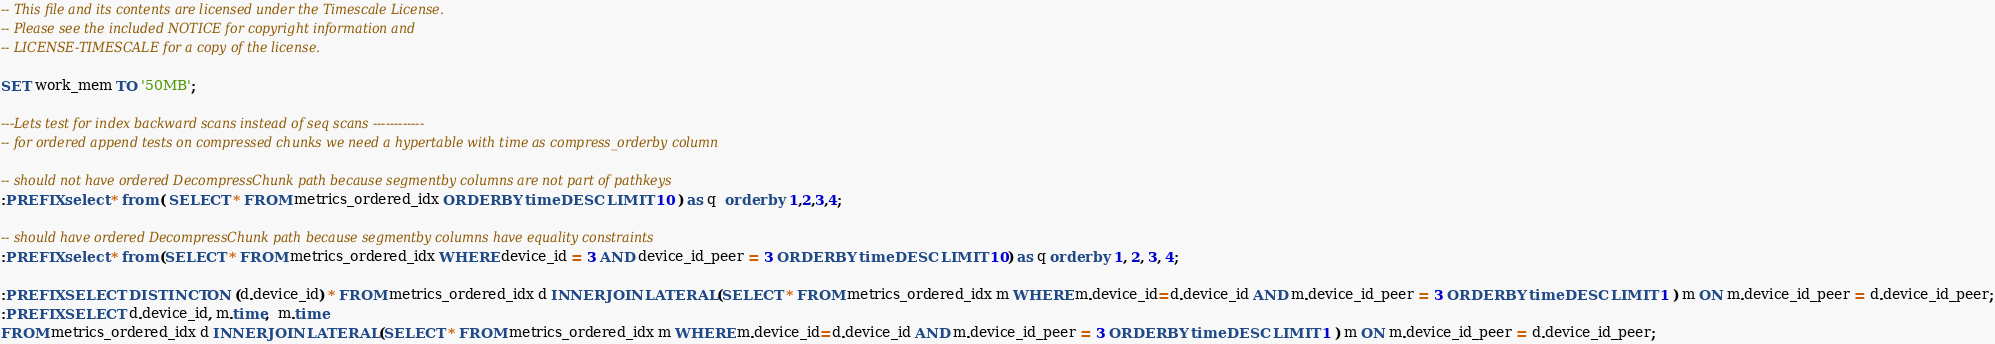<code> <loc_0><loc_0><loc_500><loc_500><_SQL_>-- This file and its contents are licensed under the Timescale License.
-- Please see the included NOTICE for copyright information and
-- LICENSE-TIMESCALE for a copy of the license.

SET work_mem TO '50MB';

---Lets test for index backward scans instead of seq scans ------------
-- for ordered append tests on compressed chunks we need a hypertable with time as compress_orderby column

-- should not have ordered DecompressChunk path because segmentby columns are not part of pathkeys
:PREFIX select * from ( SELECT * FROM metrics_ordered_idx ORDER BY time DESC LIMIT 10 ) as q  order by 1,2,3,4;

-- should have ordered DecompressChunk path because segmentby columns have equality constraints
:PREFIX select * from (SELECT * FROM metrics_ordered_idx WHERE device_id = 3 AND device_id_peer = 3 ORDER BY time DESC LIMIT 10) as q order by 1, 2, 3, 4;

:PREFIX SELECT DISTINCT ON (d.device_id) * FROM metrics_ordered_idx d INNER JOIN LATERAL (SELECT * FROM metrics_ordered_idx m WHERE m.device_id=d.device_id AND m.device_id_peer = 3 ORDER BY time DESC LIMIT 1 ) m ON m.device_id_peer = d.device_id_peer;
:PREFIX SELECT d.device_id, m.time,  m.time
FROM metrics_ordered_idx d INNER JOIN LATERAL (SELECT * FROM metrics_ordered_idx m WHERE m.device_id=d.device_id AND m.device_id_peer = 3 ORDER BY time DESC LIMIT 1 ) m ON m.device_id_peer = d.device_id_peer;

</code> 